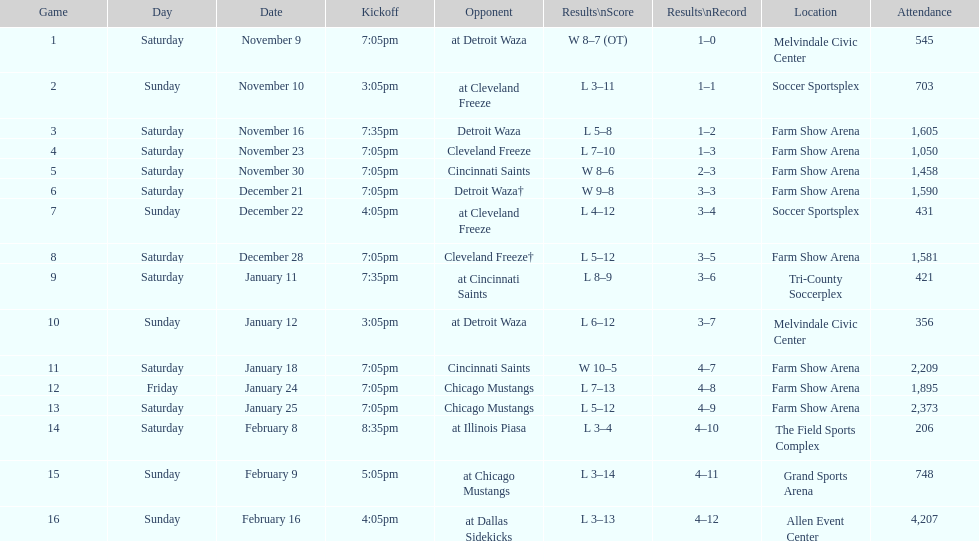Which competitor appears first in the table? Detroit Waza. 